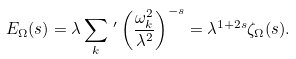<formula> <loc_0><loc_0><loc_500><loc_500>E _ { \Omega } ( s ) = \lambda \sum _ { k } \, ^ { \prime } \left ( \frac { \omega _ { k } ^ { 2 } } { \lambda ^ { 2 } } \right ) ^ { - s } = \lambda ^ { 1 + 2 s } \zeta _ { \Omega } ( s ) .</formula> 